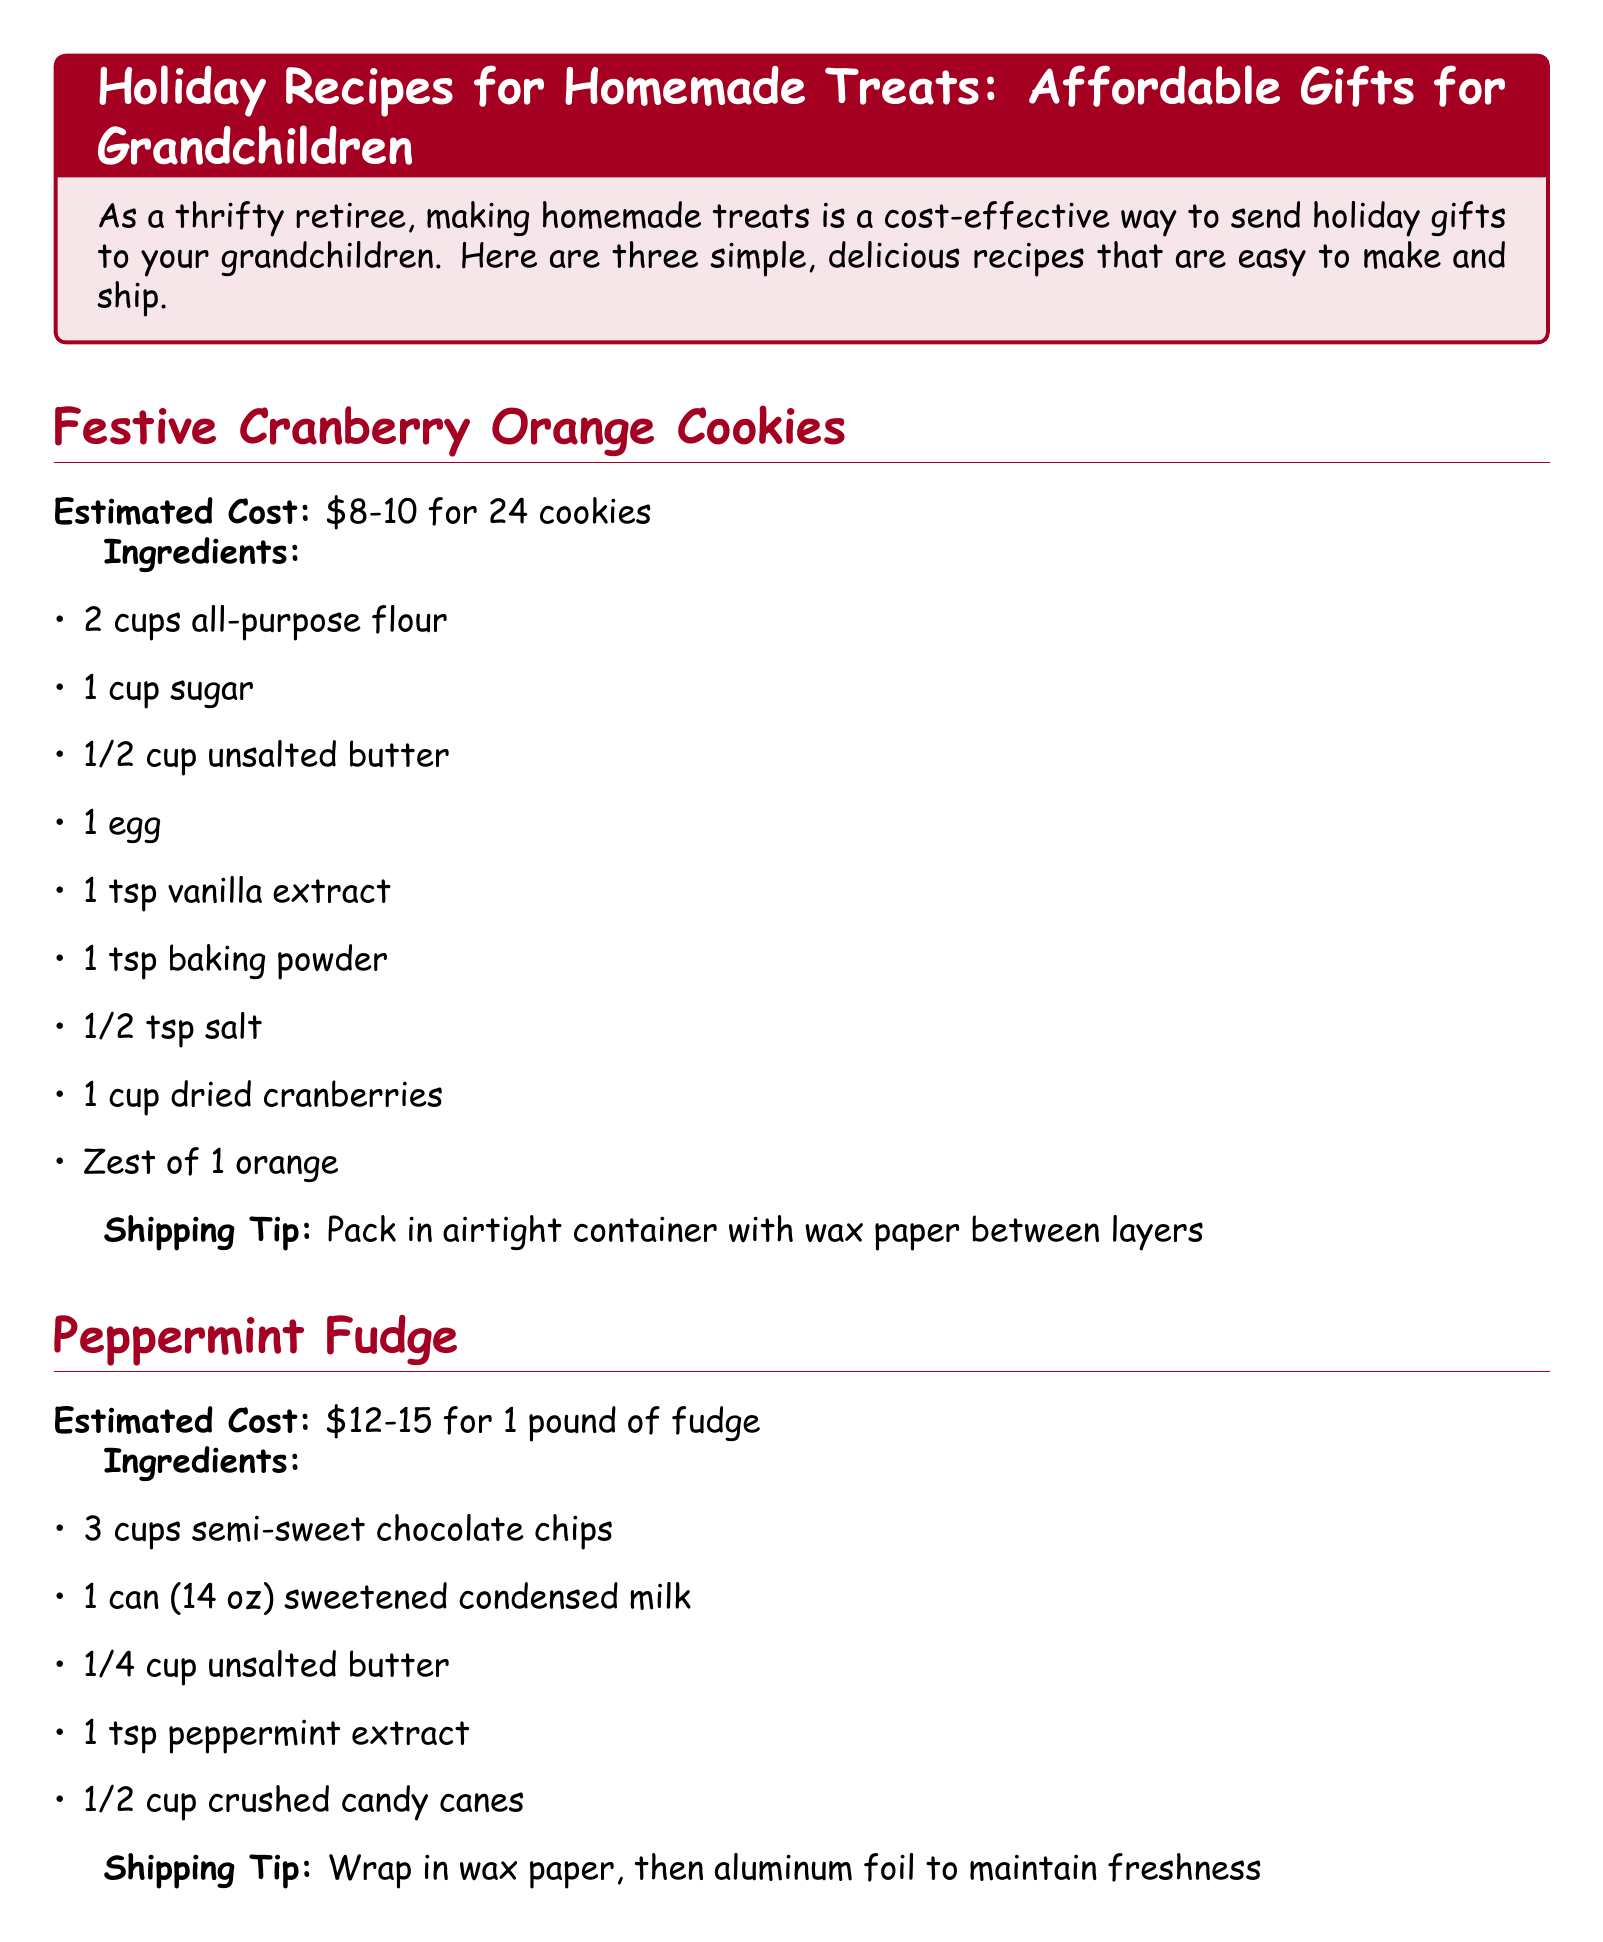What is the first recipe listed? The first recipe listed in the document is "Festive Cranberry Orange Cookies."
Answer: Festive Cranberry Orange Cookies How much do the Festive Cranberry Orange Cookies cost to make? The estimated cost for the Festive Cranberry Orange Cookies is mentioned in the document as between $8 and $10.
Answer: $8-10 What ingredient is used for flavoring in the Peppermint Fudge? The document lists "peppermint extract" as the flavoring ingredient for the Peppermint Fudge.
Answer: peppermint extract How many cups of mixed nuts are in the Spiced Honey Nut Mix? The ingredient list for the Spiced Honey Nut Mix specifies that it includes 2 cups of mixed nuts.
Answer: 2 cups What is a tip for shipping the Spiced Honey Nut Mix? The document advises packing the Spiced Honey Nut Mix in mason jars or airtight containers for shipping.
Answer: Pack in mason jars or airtight containers What is one money-saving tip provided in the document? The document offers several tips, one of which is to "Buy ingredients in bulk during holiday sales."
Answer: Buy ingredients in bulk during holiday sales What is the total estimated cost range for the Peppermint Fudge? The estimated cost range for the Peppermint Fudge is given in the document as $12 to $15.
Answer: $12-15 What does the conclusion emphasize about homemade treats? The conclusion of the document emphasizes that homemade treats are cost-effective and show care for the grandchildren.
Answer: Show your grandchildren how much you care What shipping tip is offered for the Peppermint Fudge? The shipping tip for the Peppermint Fudge is to "Wrap in wax paper, then aluminum foil to maintain freshness."
Answer: Wrap in wax paper, then aluminum foil to maintain freshness 